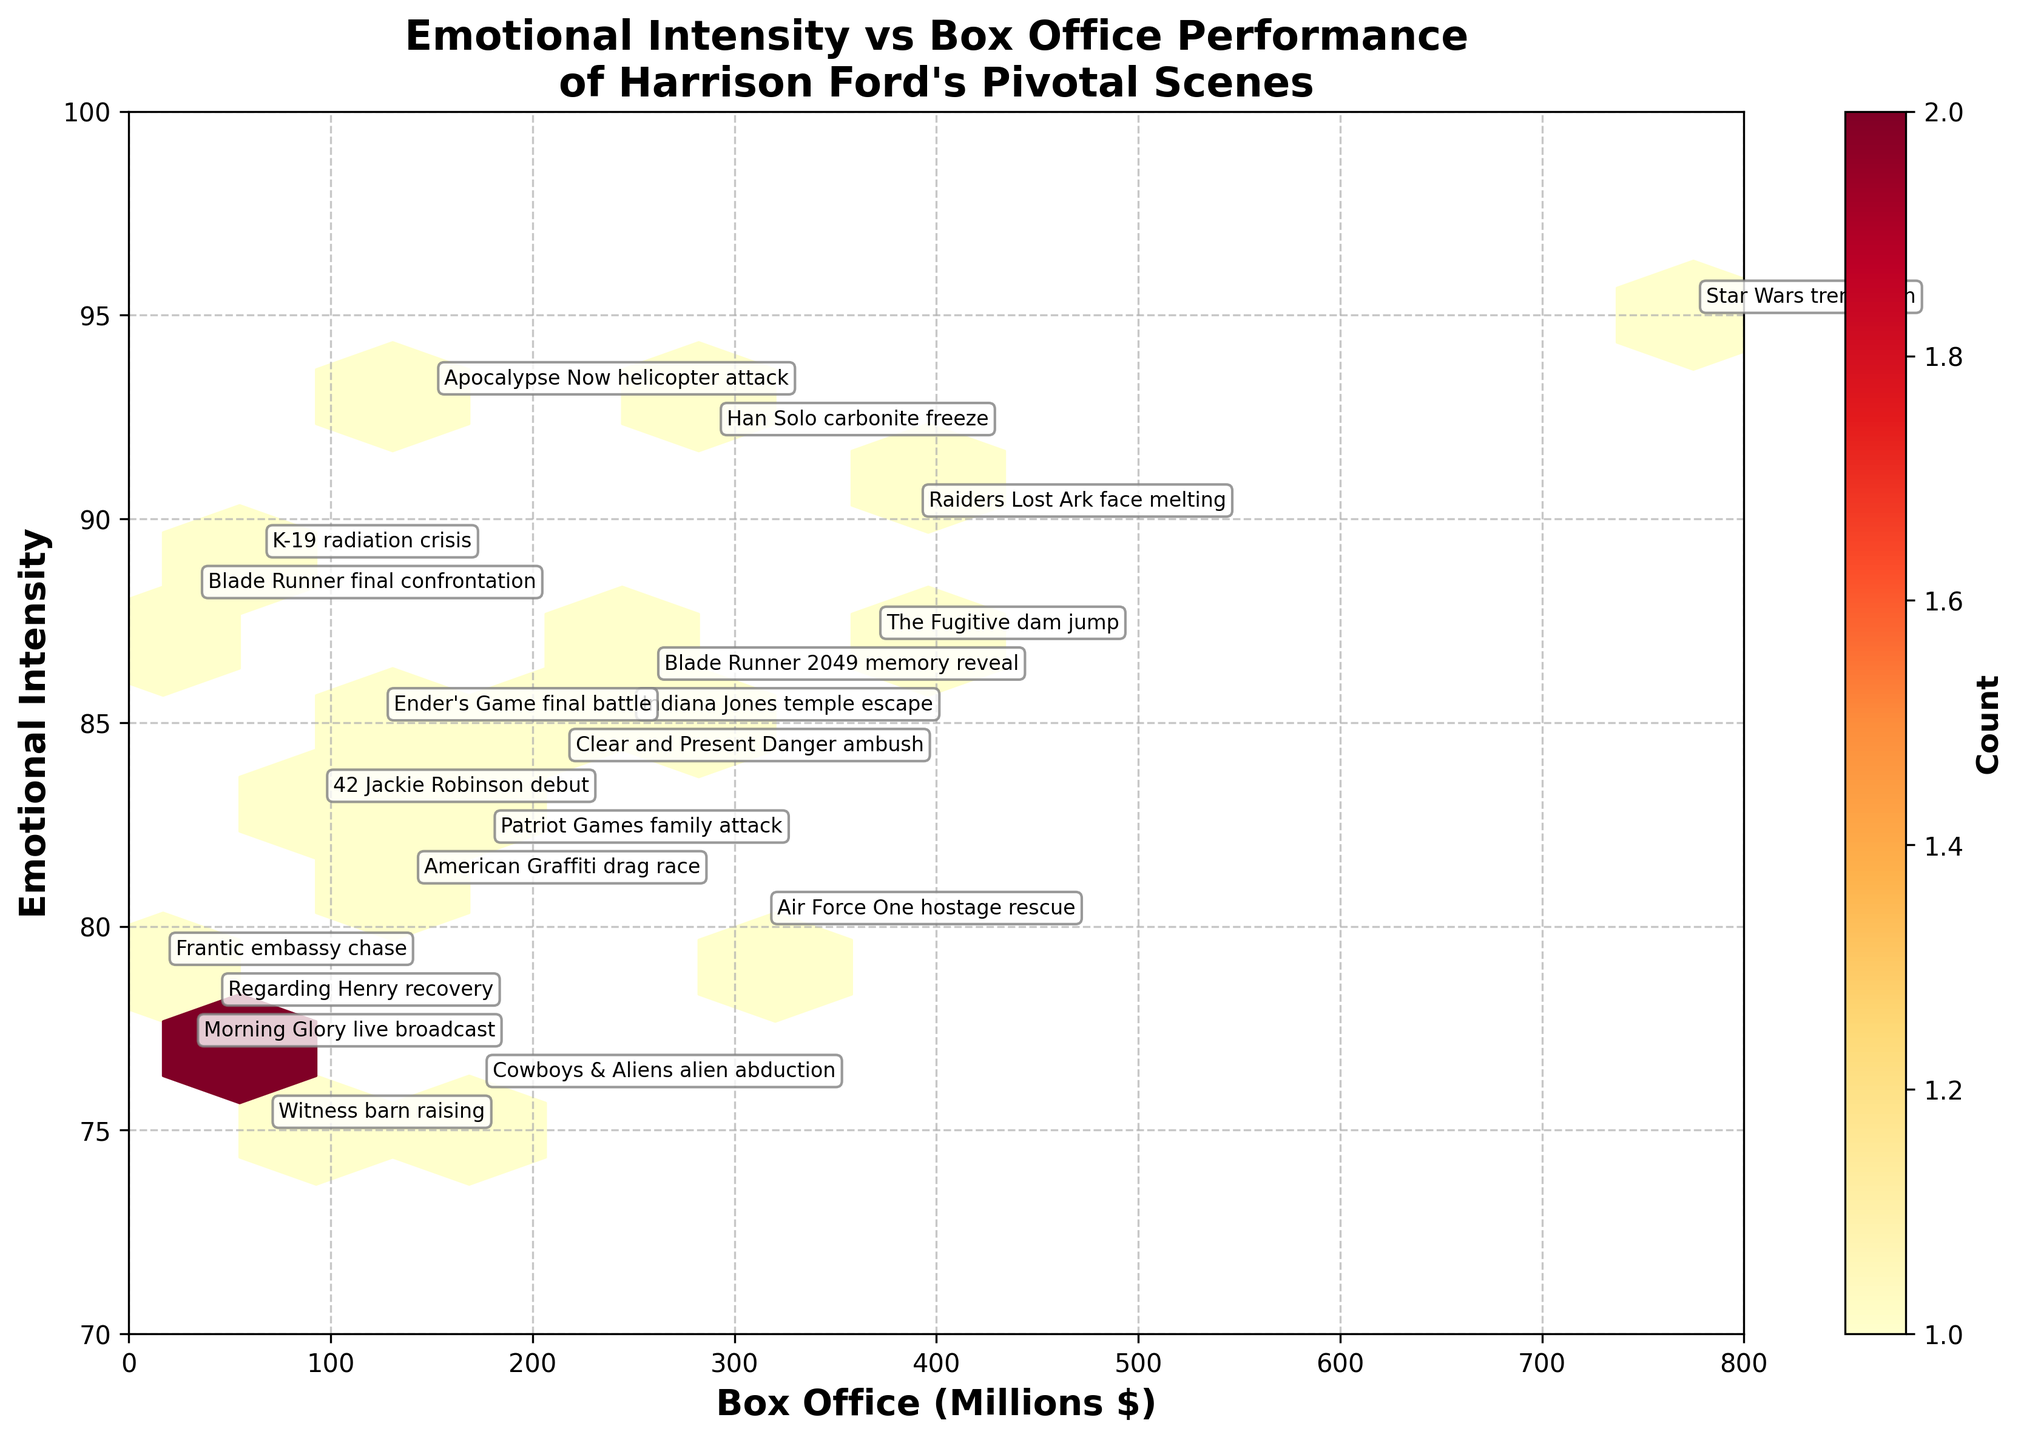What is the title of the plot? The title is usually found at the top of the figure. In this case, it is clearly written in a larger font size than other text.
Answer: "Emotional Intensity vs Box Office Performance of Harrison Ford's Pivotal Scenes" What are the x-axis and y-axis labels? Axis labels help to identify what data is being presented on each axis. In the annotated figure, the x-axis label is the horizontal text, while the y-axis label is the vertical text.
Answer: "Box Office (Millions $)" and "Emotional Intensity" Which scene has the highest emotional intensity? To find the highest emotional intensity, look for the largest value on the y-axis. Observing the annotations, the scene with the value 95 stands out.
Answer: "Star Wars trench run" Which movie has the highest box office performance, and what is its emotional intensity? To find the highest box office performance, look for the largest value on the x-axis. The annotation at 775 reveals the corresponding scene and its emotional intensity.
Answer: "Star Wars trench run", 95 How does the "Blade Runner final confrontation" scene compare to "Apocalypse Now helicopter attack" in terms of box office and emotional intensity? Look for the annotations for these two scenes: Blade Runner has box office 33 and emotional intensity 88, while Apocalypse Now has box office 150 and emotional intensity 93. Comparing these values directly provides the answer.
Answer: Blade Runner: 33, 88; Apocalypse Now: 150, 93 What is the color scheme used to represent the counts in the hexbin plot? Observe the color bar on the right side of the plot, which indicates the color scheme used in the hexbin plot. The color scheme ranges from light to dark shades to represent different counts.
Answer: "Yellows to Reds" (YlOrRd) How many hexagonal bins are used in the plot? Examine the overall plot, and count the number of hexagonal bins forming the grid. The gridsize properties directly relate to the figure's segmentations.
Answer: 10 What is the emotional intensity range represented on the y-axis? The range is determined by observing the lowest and highest values shown on the y-axis. In this figure, the range starts from 70 and goes up to 100.
Answer: 70 to 100 Why might there be a denser clustering of scenes at the higher emotional intensity levels? Identify the areas of denser clustering by examining where the hexagonal cells have darker colors and higher counts. This pattern can be attributed to Harrison Ford's ability to create memorable, high-intensity scenes.
Answer: Emotional intensity scenes tend to resonate more, leading to more frequent appearances in iconic movies Which scenes are labeled with both high box office and high emotional intensity values? Look for scenes that are annotated near the upper-right corner of the plot, indicating both high box office and high emotional intensity.
Answer: "Star Wars trench run" and "Raiders Lost Ark face melting" 